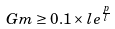Convert formula to latex. <formula><loc_0><loc_0><loc_500><loc_500>G m \geq 0 . 1 \times l e ^ { \frac { p } { l } }</formula> 